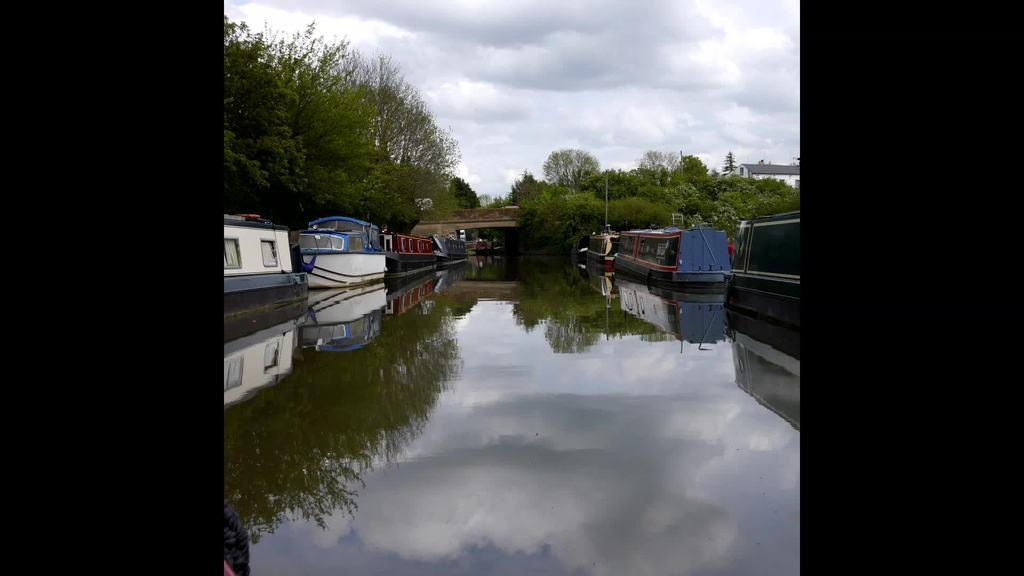What is the main subject of the image? The main subject of the image is ships. Where are the ships located? The ships are on water. What can be seen in the background of the image? There are trees in the background of the image. What type of authority is depicted on the ships in the image? There is no authority depicted on the ships in the image; it only shows the ships on water and trees in the background. How many birds can be seen flying over the ships in the image? There are no birds visible in the image; it only shows the ships on water and trees in the background. 